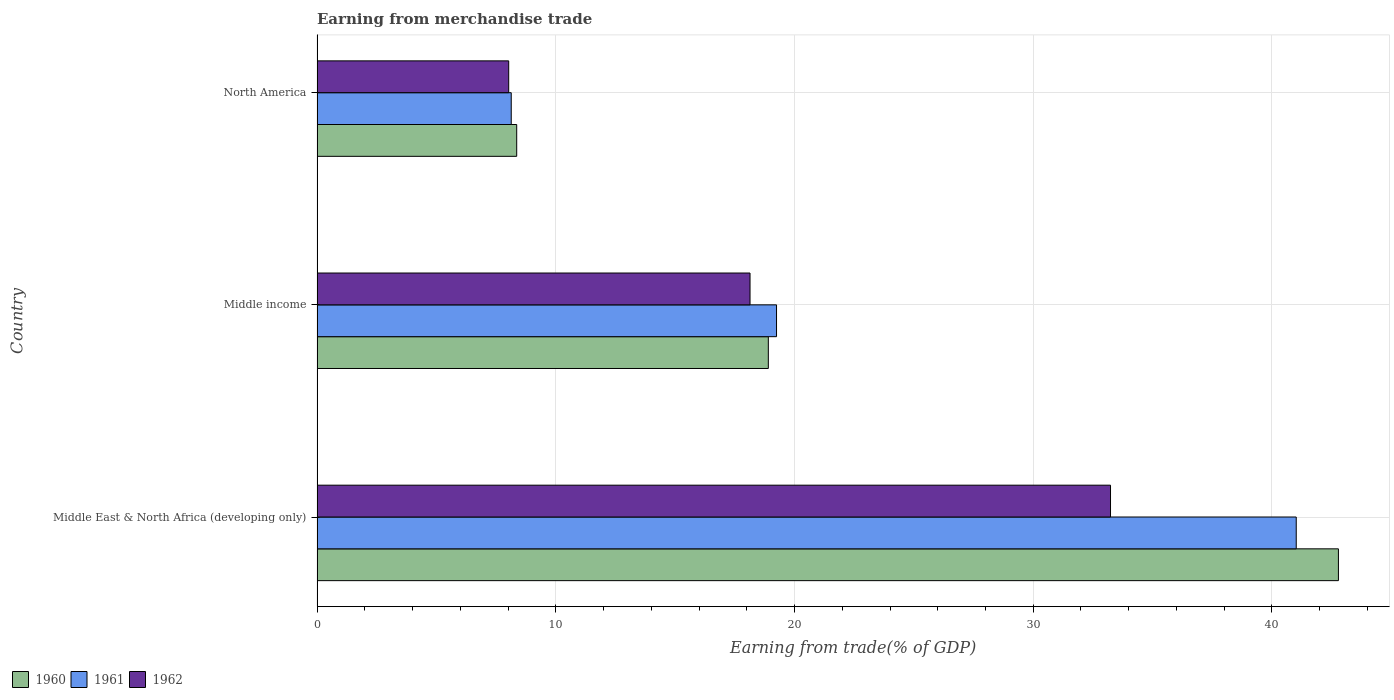How many groups of bars are there?
Provide a succinct answer. 3. Are the number of bars per tick equal to the number of legend labels?
Offer a terse response. Yes. Are the number of bars on each tick of the Y-axis equal?
Keep it short and to the point. Yes. How many bars are there on the 3rd tick from the top?
Ensure brevity in your answer.  3. What is the label of the 1st group of bars from the top?
Provide a short and direct response. North America. In how many cases, is the number of bars for a given country not equal to the number of legend labels?
Provide a succinct answer. 0. What is the earnings from trade in 1960 in Middle income?
Your response must be concise. 18.9. Across all countries, what is the maximum earnings from trade in 1961?
Keep it short and to the point. 41.02. Across all countries, what is the minimum earnings from trade in 1961?
Your answer should be compact. 8.13. In which country was the earnings from trade in 1962 maximum?
Your answer should be compact. Middle East & North Africa (developing only). In which country was the earnings from trade in 1960 minimum?
Give a very brief answer. North America. What is the total earnings from trade in 1961 in the graph?
Give a very brief answer. 68.4. What is the difference between the earnings from trade in 1960 in Middle East & North Africa (developing only) and that in Middle income?
Give a very brief answer. 23.88. What is the difference between the earnings from trade in 1961 in North America and the earnings from trade in 1960 in Middle East & North Africa (developing only)?
Keep it short and to the point. -34.65. What is the average earnings from trade in 1962 per country?
Make the answer very short. 19.8. What is the difference between the earnings from trade in 1962 and earnings from trade in 1960 in North America?
Offer a very short reply. -0.33. What is the ratio of the earnings from trade in 1960 in Middle income to that in North America?
Provide a succinct answer. 2.26. Is the difference between the earnings from trade in 1962 in Middle East & North Africa (developing only) and North America greater than the difference between the earnings from trade in 1960 in Middle East & North Africa (developing only) and North America?
Make the answer very short. No. What is the difference between the highest and the second highest earnings from trade in 1962?
Provide a short and direct response. 15.1. What is the difference between the highest and the lowest earnings from trade in 1960?
Provide a succinct answer. 34.42. Is the sum of the earnings from trade in 1961 in Middle East & North Africa (developing only) and Middle income greater than the maximum earnings from trade in 1960 across all countries?
Offer a very short reply. Yes. What does the 1st bar from the top in Middle East & North Africa (developing only) represents?
Your response must be concise. 1962. Is it the case that in every country, the sum of the earnings from trade in 1962 and earnings from trade in 1960 is greater than the earnings from trade in 1961?
Provide a succinct answer. Yes. How many countries are there in the graph?
Give a very brief answer. 3. Where does the legend appear in the graph?
Keep it short and to the point. Bottom left. What is the title of the graph?
Keep it short and to the point. Earning from merchandise trade. What is the label or title of the X-axis?
Offer a very short reply. Earning from trade(% of GDP). What is the label or title of the Y-axis?
Keep it short and to the point. Country. What is the Earning from trade(% of GDP) of 1960 in Middle East & North Africa (developing only)?
Provide a succinct answer. 42.78. What is the Earning from trade(% of GDP) of 1961 in Middle East & North Africa (developing only)?
Offer a very short reply. 41.02. What is the Earning from trade(% of GDP) in 1962 in Middle East & North Africa (developing only)?
Provide a short and direct response. 33.24. What is the Earning from trade(% of GDP) in 1960 in Middle income?
Offer a terse response. 18.9. What is the Earning from trade(% of GDP) of 1961 in Middle income?
Ensure brevity in your answer.  19.25. What is the Earning from trade(% of GDP) of 1962 in Middle income?
Make the answer very short. 18.14. What is the Earning from trade(% of GDP) of 1960 in North America?
Offer a very short reply. 8.36. What is the Earning from trade(% of GDP) of 1961 in North America?
Make the answer very short. 8.13. What is the Earning from trade(% of GDP) of 1962 in North America?
Your response must be concise. 8.03. Across all countries, what is the maximum Earning from trade(% of GDP) in 1960?
Keep it short and to the point. 42.78. Across all countries, what is the maximum Earning from trade(% of GDP) of 1961?
Provide a succinct answer. 41.02. Across all countries, what is the maximum Earning from trade(% of GDP) in 1962?
Provide a succinct answer. 33.24. Across all countries, what is the minimum Earning from trade(% of GDP) in 1960?
Ensure brevity in your answer.  8.36. Across all countries, what is the minimum Earning from trade(% of GDP) in 1961?
Your answer should be very brief. 8.13. Across all countries, what is the minimum Earning from trade(% of GDP) of 1962?
Your answer should be very brief. 8.03. What is the total Earning from trade(% of GDP) in 1960 in the graph?
Ensure brevity in your answer.  70.05. What is the total Earning from trade(% of GDP) in 1961 in the graph?
Your answer should be compact. 68.4. What is the total Earning from trade(% of GDP) in 1962 in the graph?
Your answer should be very brief. 59.4. What is the difference between the Earning from trade(% of GDP) in 1960 in Middle East & North Africa (developing only) and that in Middle income?
Provide a succinct answer. 23.88. What is the difference between the Earning from trade(% of GDP) of 1961 in Middle East & North Africa (developing only) and that in Middle income?
Provide a succinct answer. 21.77. What is the difference between the Earning from trade(% of GDP) of 1962 in Middle East & North Africa (developing only) and that in Middle income?
Your response must be concise. 15.1. What is the difference between the Earning from trade(% of GDP) in 1960 in Middle East & North Africa (developing only) and that in North America?
Provide a succinct answer. 34.42. What is the difference between the Earning from trade(% of GDP) of 1961 in Middle East & North Africa (developing only) and that in North America?
Make the answer very short. 32.88. What is the difference between the Earning from trade(% of GDP) of 1962 in Middle East & North Africa (developing only) and that in North America?
Your response must be concise. 25.21. What is the difference between the Earning from trade(% of GDP) in 1960 in Middle income and that in North America?
Offer a terse response. 10.54. What is the difference between the Earning from trade(% of GDP) in 1961 in Middle income and that in North America?
Provide a short and direct response. 11.11. What is the difference between the Earning from trade(% of GDP) of 1962 in Middle income and that in North America?
Give a very brief answer. 10.11. What is the difference between the Earning from trade(% of GDP) in 1960 in Middle East & North Africa (developing only) and the Earning from trade(% of GDP) in 1961 in Middle income?
Your response must be concise. 23.54. What is the difference between the Earning from trade(% of GDP) of 1960 in Middle East & North Africa (developing only) and the Earning from trade(% of GDP) of 1962 in Middle income?
Offer a terse response. 24.65. What is the difference between the Earning from trade(% of GDP) in 1961 in Middle East & North Africa (developing only) and the Earning from trade(% of GDP) in 1962 in Middle income?
Ensure brevity in your answer.  22.88. What is the difference between the Earning from trade(% of GDP) of 1960 in Middle East & North Africa (developing only) and the Earning from trade(% of GDP) of 1961 in North America?
Offer a very short reply. 34.65. What is the difference between the Earning from trade(% of GDP) in 1960 in Middle East & North Africa (developing only) and the Earning from trade(% of GDP) in 1962 in North America?
Your answer should be compact. 34.76. What is the difference between the Earning from trade(% of GDP) in 1961 in Middle East & North Africa (developing only) and the Earning from trade(% of GDP) in 1962 in North America?
Provide a short and direct response. 32.99. What is the difference between the Earning from trade(% of GDP) in 1960 in Middle income and the Earning from trade(% of GDP) in 1961 in North America?
Your answer should be very brief. 10.77. What is the difference between the Earning from trade(% of GDP) in 1960 in Middle income and the Earning from trade(% of GDP) in 1962 in North America?
Give a very brief answer. 10.88. What is the difference between the Earning from trade(% of GDP) in 1961 in Middle income and the Earning from trade(% of GDP) in 1962 in North America?
Your answer should be compact. 11.22. What is the average Earning from trade(% of GDP) of 1960 per country?
Ensure brevity in your answer.  23.35. What is the average Earning from trade(% of GDP) of 1961 per country?
Provide a succinct answer. 22.8. What is the average Earning from trade(% of GDP) of 1962 per country?
Offer a terse response. 19.8. What is the difference between the Earning from trade(% of GDP) in 1960 and Earning from trade(% of GDP) in 1961 in Middle East & North Africa (developing only)?
Your answer should be compact. 1.77. What is the difference between the Earning from trade(% of GDP) of 1960 and Earning from trade(% of GDP) of 1962 in Middle East & North Africa (developing only)?
Make the answer very short. 9.55. What is the difference between the Earning from trade(% of GDP) of 1961 and Earning from trade(% of GDP) of 1962 in Middle East & North Africa (developing only)?
Offer a terse response. 7.78. What is the difference between the Earning from trade(% of GDP) of 1960 and Earning from trade(% of GDP) of 1961 in Middle income?
Provide a succinct answer. -0.34. What is the difference between the Earning from trade(% of GDP) of 1960 and Earning from trade(% of GDP) of 1962 in Middle income?
Provide a short and direct response. 0.77. What is the difference between the Earning from trade(% of GDP) in 1961 and Earning from trade(% of GDP) in 1962 in Middle income?
Your answer should be very brief. 1.11. What is the difference between the Earning from trade(% of GDP) in 1960 and Earning from trade(% of GDP) in 1961 in North America?
Offer a terse response. 0.23. What is the difference between the Earning from trade(% of GDP) of 1960 and Earning from trade(% of GDP) of 1962 in North America?
Offer a very short reply. 0.33. What is the difference between the Earning from trade(% of GDP) in 1961 and Earning from trade(% of GDP) in 1962 in North America?
Provide a short and direct response. 0.11. What is the ratio of the Earning from trade(% of GDP) of 1960 in Middle East & North Africa (developing only) to that in Middle income?
Offer a very short reply. 2.26. What is the ratio of the Earning from trade(% of GDP) in 1961 in Middle East & North Africa (developing only) to that in Middle income?
Provide a short and direct response. 2.13. What is the ratio of the Earning from trade(% of GDP) of 1962 in Middle East & North Africa (developing only) to that in Middle income?
Your answer should be very brief. 1.83. What is the ratio of the Earning from trade(% of GDP) of 1960 in Middle East & North Africa (developing only) to that in North America?
Your answer should be compact. 5.12. What is the ratio of the Earning from trade(% of GDP) of 1961 in Middle East & North Africa (developing only) to that in North America?
Ensure brevity in your answer.  5.04. What is the ratio of the Earning from trade(% of GDP) of 1962 in Middle East & North Africa (developing only) to that in North America?
Keep it short and to the point. 4.14. What is the ratio of the Earning from trade(% of GDP) of 1960 in Middle income to that in North America?
Offer a terse response. 2.26. What is the ratio of the Earning from trade(% of GDP) in 1961 in Middle income to that in North America?
Make the answer very short. 2.37. What is the ratio of the Earning from trade(% of GDP) of 1962 in Middle income to that in North America?
Provide a succinct answer. 2.26. What is the difference between the highest and the second highest Earning from trade(% of GDP) of 1960?
Make the answer very short. 23.88. What is the difference between the highest and the second highest Earning from trade(% of GDP) in 1961?
Make the answer very short. 21.77. What is the difference between the highest and the second highest Earning from trade(% of GDP) in 1962?
Give a very brief answer. 15.1. What is the difference between the highest and the lowest Earning from trade(% of GDP) in 1960?
Offer a very short reply. 34.42. What is the difference between the highest and the lowest Earning from trade(% of GDP) of 1961?
Your response must be concise. 32.88. What is the difference between the highest and the lowest Earning from trade(% of GDP) in 1962?
Provide a succinct answer. 25.21. 